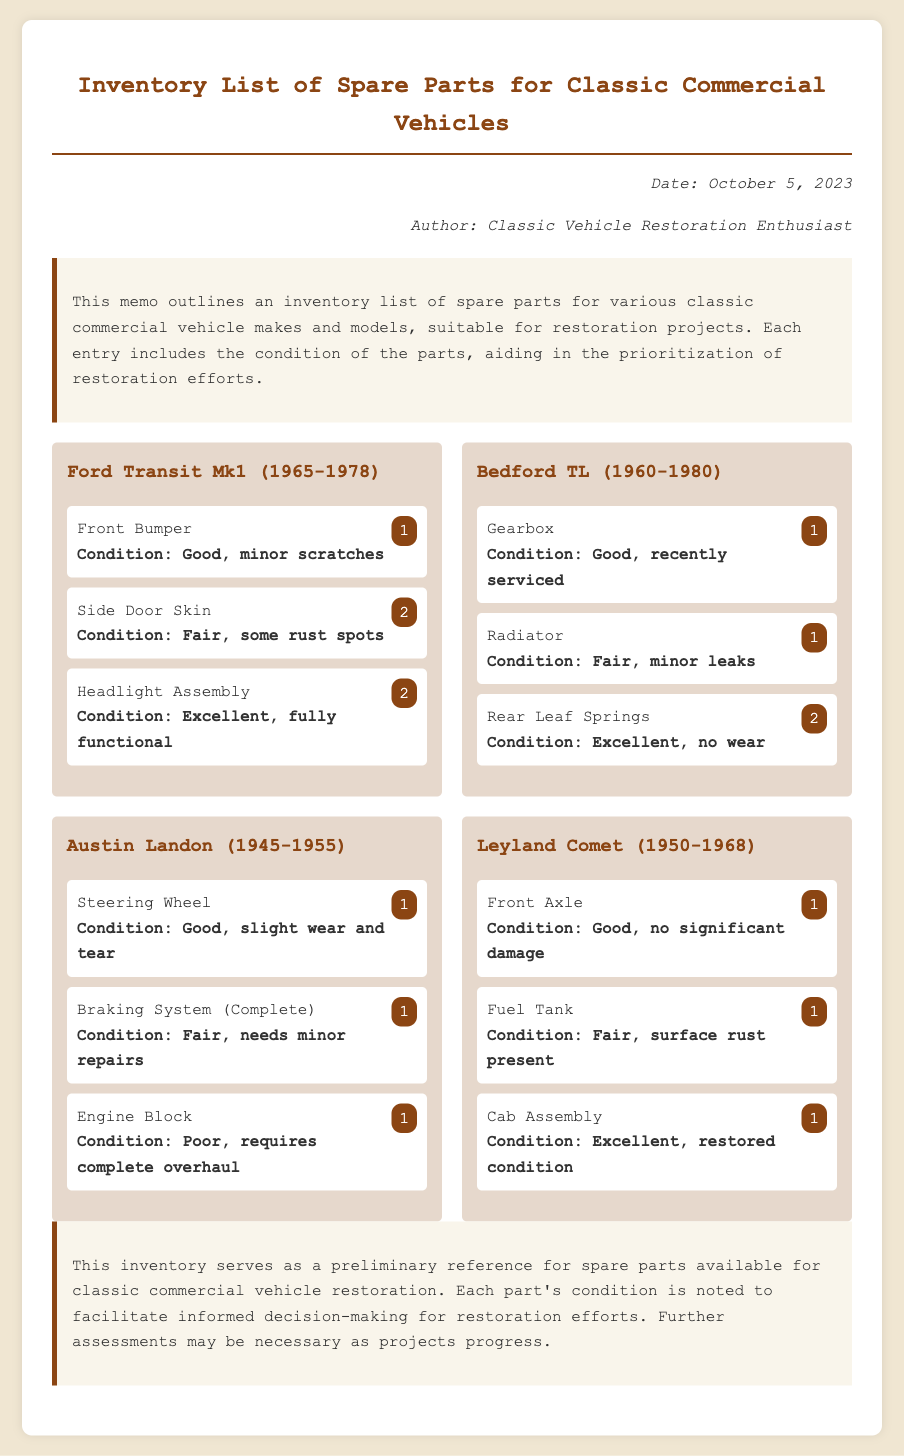What is the date of the memo? The date of the memo is stated in the meta section of the document as October 5, 2023.
Answer: October 5, 2023 Who is the author of the memo? The author is mentioned in the meta section, credited as Classic Vehicle Restoration Enthusiast.
Answer: Classic Vehicle Restoration Enthusiast How many parts are listed for the Ford Transit Mk1? The document lists three parts under the Ford Transit Mk1 heading, as indicated in the vehicle section.
Answer: 3 What is the condition of the Engine Block for the Austin Landon? The condition of the Engine Block is noted as Poor, requiring a complete overhaul in the parts list.
Answer: Poor, requires complete overhaul Which vehicle has a Fender Bumper in the inventory? There is no Fender Bumper listed; instead, the Ford Transit Mk1 has a Front Bumper, which is the closest match.
Answer: None What part has the most quantity available from the Bedford TL? The Rear Leaf Springs are listed with a quantity of two, which is the most for this vehicle.
Answer: 2 Which part from the Leyland Comet is described as in restored condition? The Cab Assembly is mentioned as being in restored condition in the parts list for the Leyland Comet.
Answer: Cab Assembly What is the condition of the Fuel Tank for the Leyland Comet? The condition is noted as Fair, with surface rust present in the description.
Answer: Fair, surface rust present 